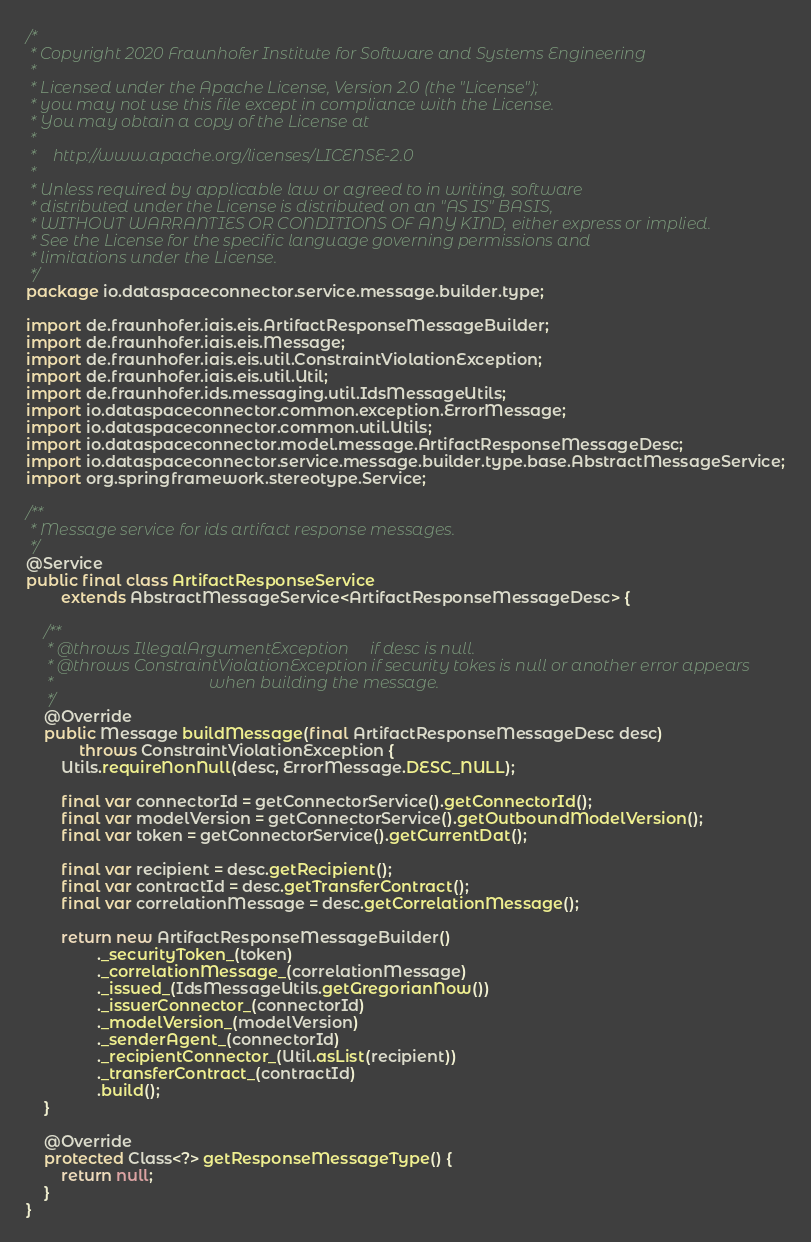<code> <loc_0><loc_0><loc_500><loc_500><_Java_>/*
 * Copyright 2020 Fraunhofer Institute for Software and Systems Engineering
 *
 * Licensed under the Apache License, Version 2.0 (the "License");
 * you may not use this file except in compliance with the License.
 * You may obtain a copy of the License at
 *
 *    http://www.apache.org/licenses/LICENSE-2.0
 *
 * Unless required by applicable law or agreed to in writing, software
 * distributed under the License is distributed on an "AS IS" BASIS,
 * WITHOUT WARRANTIES OR CONDITIONS OF ANY KIND, either express or implied.
 * See the License for the specific language governing permissions and
 * limitations under the License.
 */
package io.dataspaceconnector.service.message.builder.type;

import de.fraunhofer.iais.eis.ArtifactResponseMessageBuilder;
import de.fraunhofer.iais.eis.Message;
import de.fraunhofer.iais.eis.util.ConstraintViolationException;
import de.fraunhofer.iais.eis.util.Util;
import de.fraunhofer.ids.messaging.util.IdsMessageUtils;
import io.dataspaceconnector.common.exception.ErrorMessage;
import io.dataspaceconnector.common.util.Utils;
import io.dataspaceconnector.model.message.ArtifactResponseMessageDesc;
import io.dataspaceconnector.service.message.builder.type.base.AbstractMessageService;
import org.springframework.stereotype.Service;

/**
 * Message service for ids artifact response messages.
 */
@Service
public final class ArtifactResponseService
        extends AbstractMessageService<ArtifactResponseMessageDesc> {

    /**
     * @throws IllegalArgumentException     if desc is null.
     * @throws ConstraintViolationException if security tokes is null or another error appears
     *                                      when building the message.
     */
    @Override
    public Message buildMessage(final ArtifactResponseMessageDesc desc)
            throws ConstraintViolationException {
        Utils.requireNonNull(desc, ErrorMessage.DESC_NULL);

        final var connectorId = getConnectorService().getConnectorId();
        final var modelVersion = getConnectorService().getOutboundModelVersion();
        final var token = getConnectorService().getCurrentDat();

        final var recipient = desc.getRecipient();
        final var contractId = desc.getTransferContract();
        final var correlationMessage = desc.getCorrelationMessage();

        return new ArtifactResponseMessageBuilder()
                ._securityToken_(token)
                ._correlationMessage_(correlationMessage)
                ._issued_(IdsMessageUtils.getGregorianNow())
                ._issuerConnector_(connectorId)
                ._modelVersion_(modelVersion)
                ._senderAgent_(connectorId)
                ._recipientConnector_(Util.asList(recipient))
                ._transferContract_(contractId)
                .build();
    }

    @Override
    protected Class<?> getResponseMessageType() {
        return null;
    }
}
</code> 